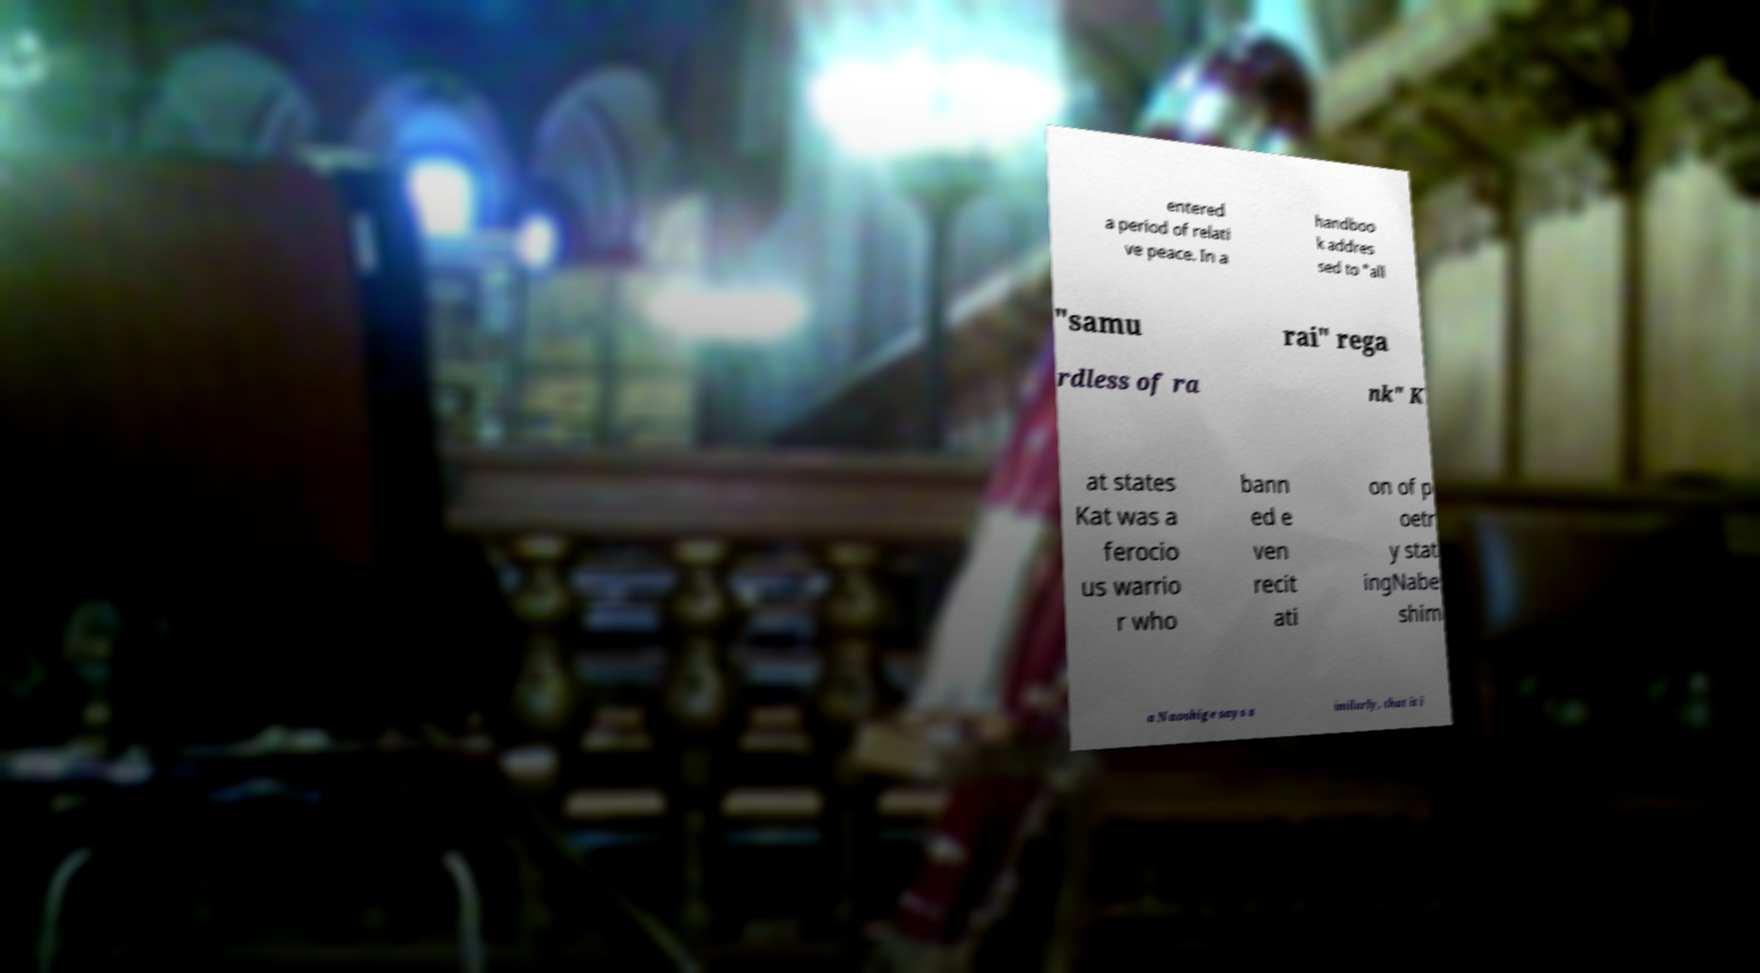Could you assist in decoding the text presented in this image and type it out clearly? entered a period of relati ve peace. In a handboo k addres sed to "all "samu rai" rega rdless of ra nk" K at states Kat was a ferocio us warrio r who bann ed e ven recit ati on of p oetr y stat ingNabe shim a Naoshige says s imilarly, that it i 